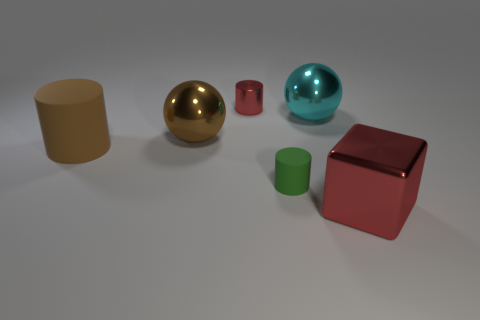Add 1 tiny matte things. How many objects exist? 7 Subtract all blocks. How many objects are left? 5 Subtract all large red shiny cubes. Subtract all big matte cylinders. How many objects are left? 4 Add 3 big cylinders. How many big cylinders are left? 4 Add 5 big red rubber cylinders. How many big red rubber cylinders exist? 5 Subtract 0 yellow cylinders. How many objects are left? 6 